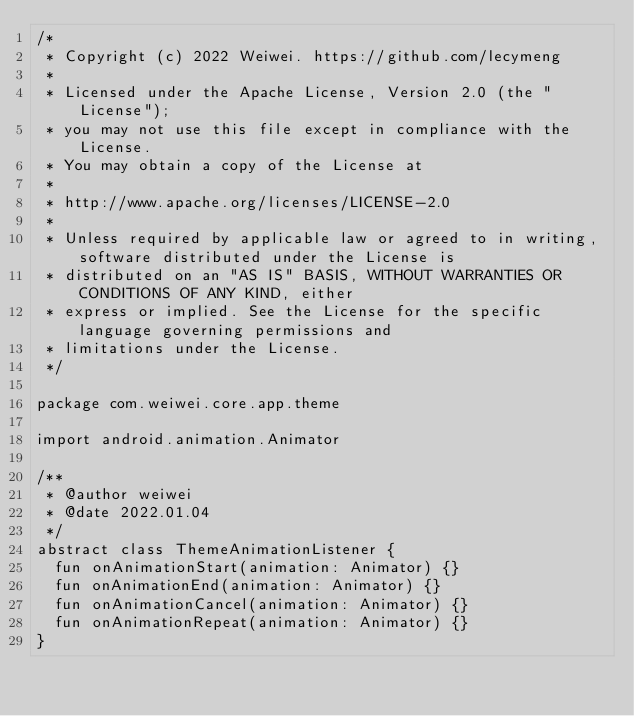Convert code to text. <code><loc_0><loc_0><loc_500><loc_500><_Kotlin_>/*
 * Copyright (c) 2022 Weiwei. https://github.com/lecymeng
 *
 * Licensed under the Apache License, Version 2.0 (the "License");
 * you may not use this file except in compliance with the License.
 * You may obtain a copy of the License at
 *
 * http://www.apache.org/licenses/LICENSE-2.0
 *
 * Unless required by applicable law or agreed to in writing, software distributed under the License is
 * distributed on an "AS IS" BASIS, WITHOUT WARRANTIES OR CONDITIONS OF ANY KIND, either
 * express or implied. See the License for the specific language governing permissions and
 * limitations under the License.
 */

package com.weiwei.core.app.theme

import android.animation.Animator

/**
 * @author weiwei
 * @date 2022.01.04
 */
abstract class ThemeAnimationListener {
  fun onAnimationStart(animation: Animator) {}
  fun onAnimationEnd(animation: Animator) {}
  fun onAnimationCancel(animation: Animator) {}
  fun onAnimationRepeat(animation: Animator) {}
}</code> 